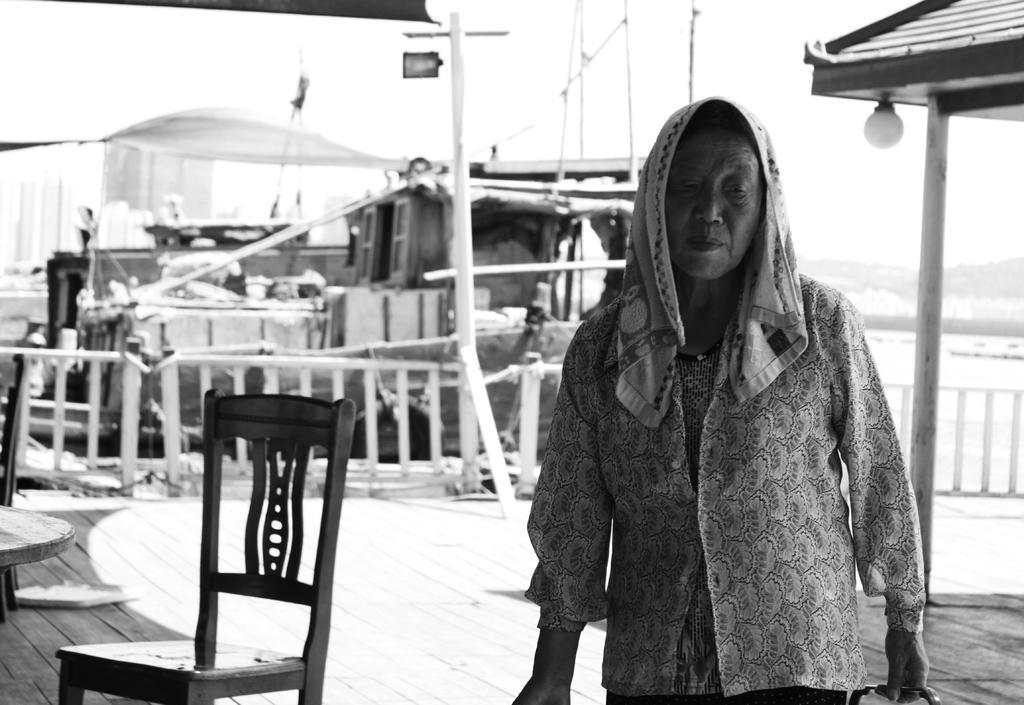Can you describe this image briefly? In this image I can see the person holding some object. In the background I can see the chair and I can also see the boat on the water and the image is in black and white. 